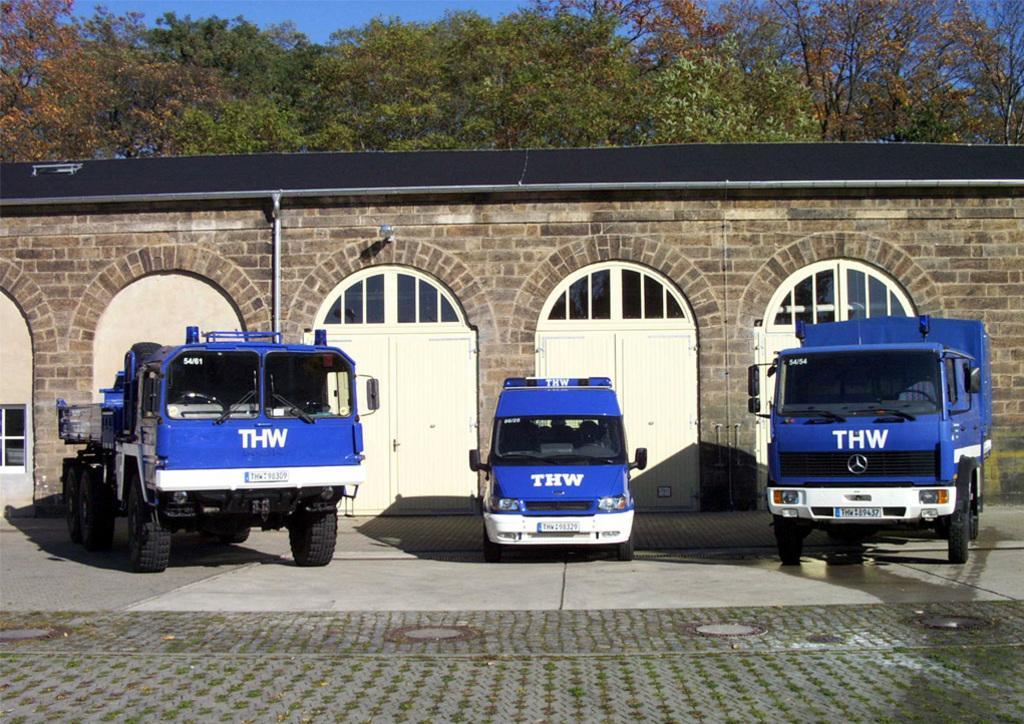Could you give a brief overview of what you see in this image? There are vehicles on the road. Here we can see doors and wall. In the background there are trees and sky. 